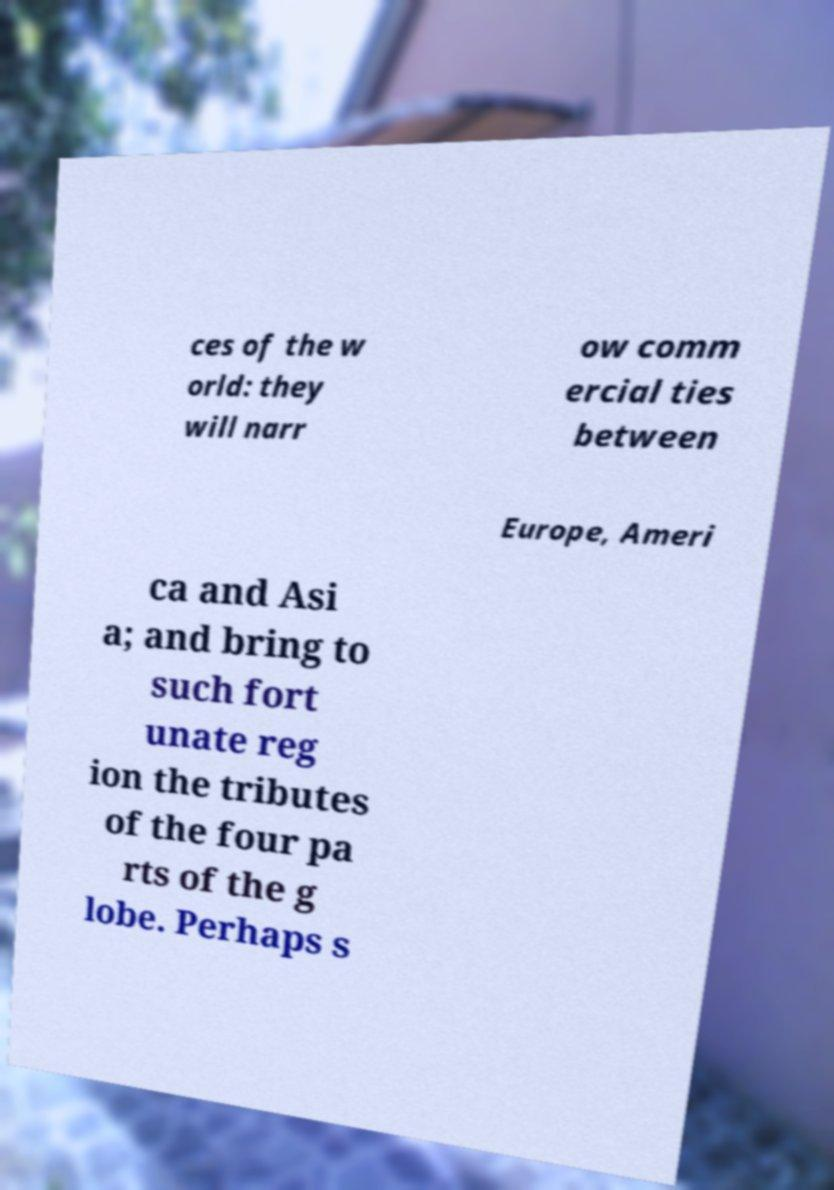Can you read and provide the text displayed in the image?This photo seems to have some interesting text. Can you extract and type it out for me? ces of the w orld: they will narr ow comm ercial ties between Europe, Ameri ca and Asi a; and bring to such fort unate reg ion the tributes of the four pa rts of the g lobe. Perhaps s 